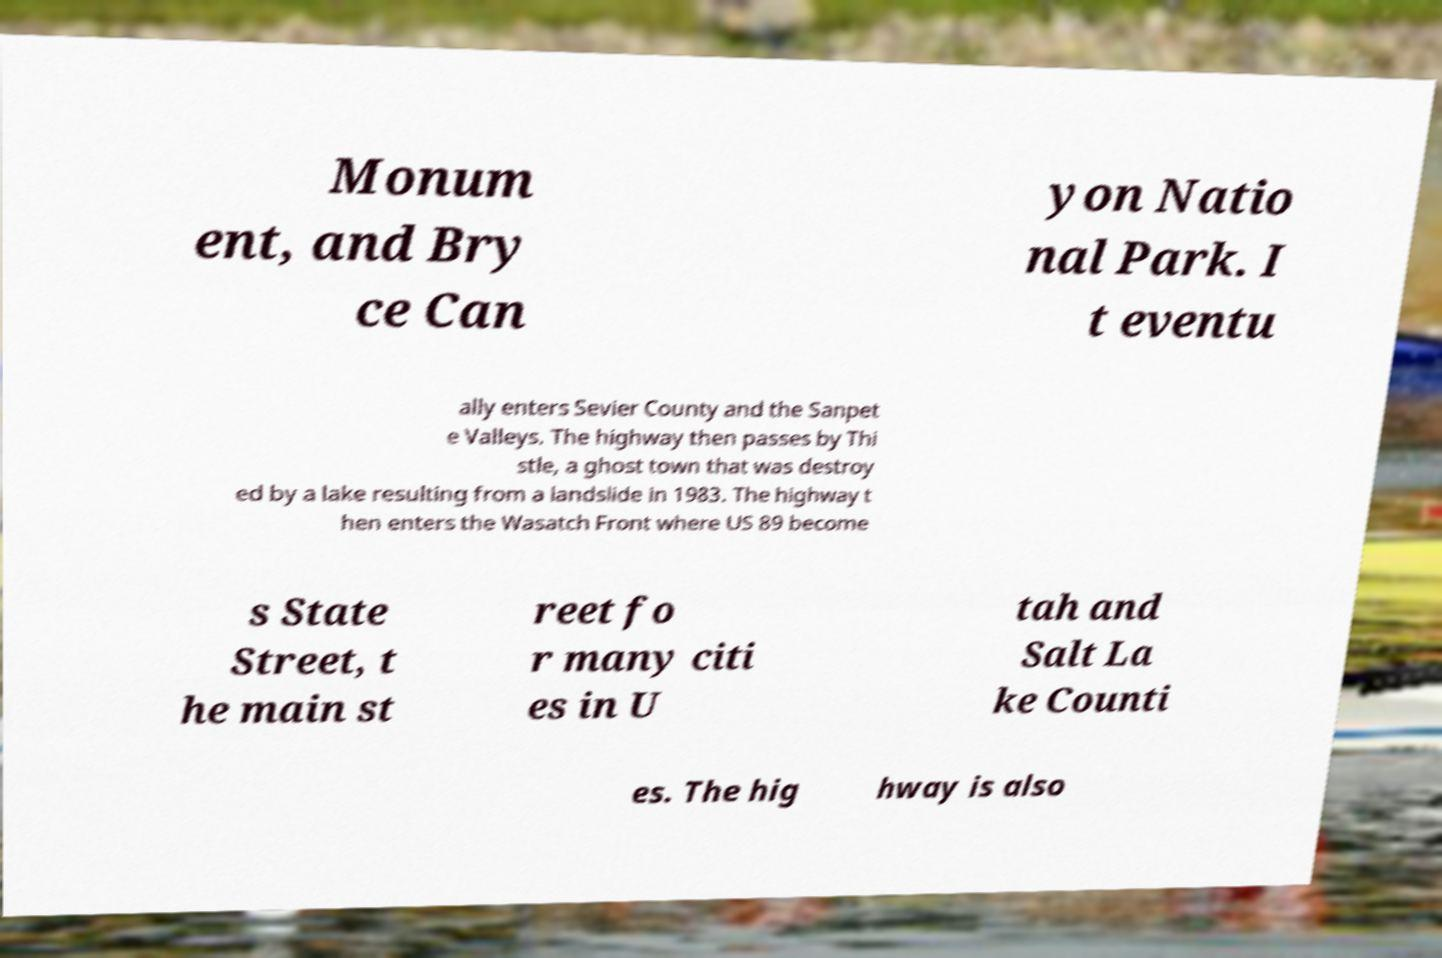Please identify and transcribe the text found in this image. Monum ent, and Bry ce Can yon Natio nal Park. I t eventu ally enters Sevier County and the Sanpet e Valleys. The highway then passes by Thi stle, a ghost town that was destroy ed by a lake resulting from a landslide in 1983. The highway t hen enters the Wasatch Front where US 89 become s State Street, t he main st reet fo r many citi es in U tah and Salt La ke Counti es. The hig hway is also 